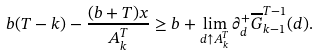<formula> <loc_0><loc_0><loc_500><loc_500>b ( T - k ) - \frac { ( b + T ) x } { A ^ { T } _ { k } } \geq b + \lim _ { d \uparrow A ^ { T } _ { k } } \partial ^ { + } _ { d } \overline { G } ^ { T - 1 } _ { k - 1 } ( d ) .</formula> 